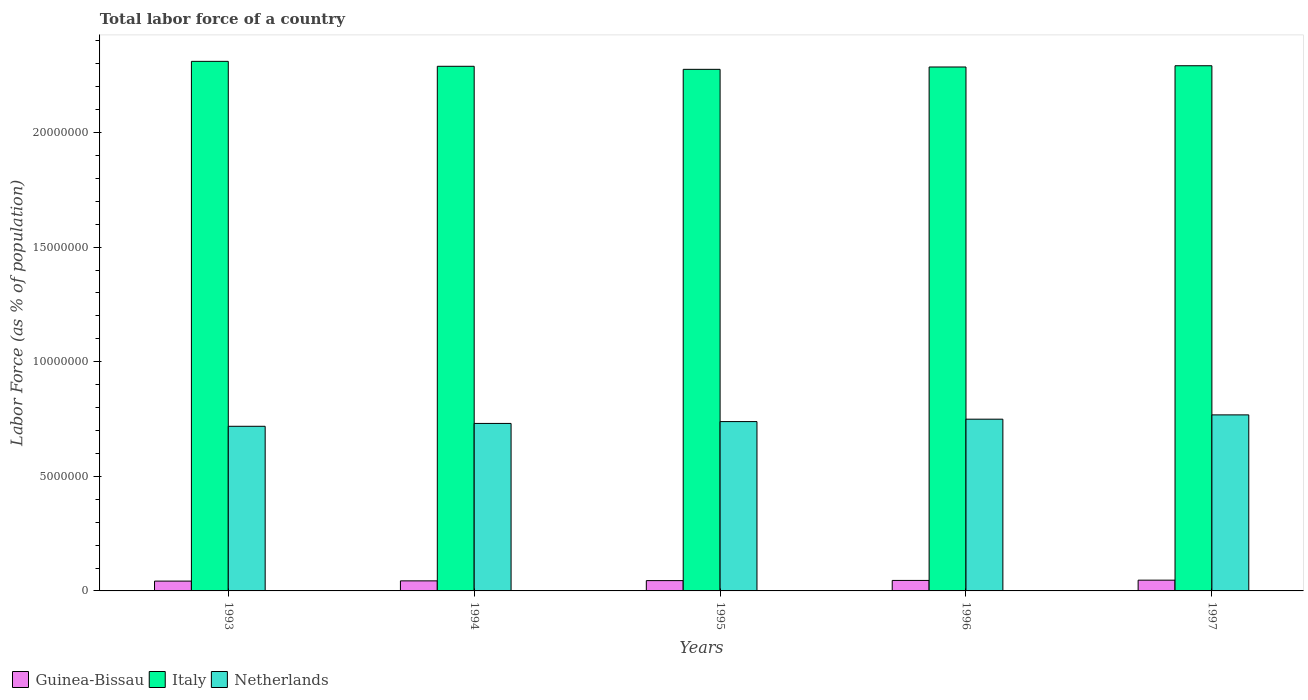How many groups of bars are there?
Provide a succinct answer. 5. Are the number of bars on each tick of the X-axis equal?
Ensure brevity in your answer.  Yes. How many bars are there on the 2nd tick from the right?
Provide a succinct answer. 3. What is the label of the 1st group of bars from the left?
Offer a very short reply. 1993. What is the percentage of labor force in Italy in 1996?
Your answer should be very brief. 2.29e+07. Across all years, what is the maximum percentage of labor force in Netherlands?
Make the answer very short. 7.68e+06. Across all years, what is the minimum percentage of labor force in Italy?
Your answer should be compact. 2.28e+07. What is the total percentage of labor force in Netherlands in the graph?
Your response must be concise. 3.71e+07. What is the difference between the percentage of labor force in Netherlands in 1995 and that in 1996?
Your answer should be very brief. -1.05e+05. What is the difference between the percentage of labor force in Netherlands in 1994 and the percentage of labor force in Guinea-Bissau in 1995?
Ensure brevity in your answer.  6.86e+06. What is the average percentage of labor force in Italy per year?
Your response must be concise. 2.29e+07. In the year 1997, what is the difference between the percentage of labor force in Guinea-Bissau and percentage of labor force in Netherlands?
Give a very brief answer. -7.21e+06. What is the ratio of the percentage of labor force in Italy in 1996 to that in 1997?
Your response must be concise. 1. Is the difference between the percentage of labor force in Guinea-Bissau in 1996 and 1997 greater than the difference between the percentage of labor force in Netherlands in 1996 and 1997?
Give a very brief answer. Yes. What is the difference between the highest and the second highest percentage of labor force in Guinea-Bissau?
Make the answer very short. 1.15e+04. What is the difference between the highest and the lowest percentage of labor force in Guinea-Bissau?
Your answer should be compact. 4.11e+04. Is the sum of the percentage of labor force in Italy in 1994 and 1995 greater than the maximum percentage of labor force in Netherlands across all years?
Your response must be concise. Yes. What does the 3rd bar from the right in 1993 represents?
Keep it short and to the point. Guinea-Bissau. Are all the bars in the graph horizontal?
Make the answer very short. No. How many years are there in the graph?
Provide a short and direct response. 5. Where does the legend appear in the graph?
Keep it short and to the point. Bottom left. How are the legend labels stacked?
Provide a short and direct response. Horizontal. What is the title of the graph?
Your answer should be compact. Total labor force of a country. What is the label or title of the Y-axis?
Make the answer very short. Labor Force (as % of population). What is the Labor Force (as % of population) in Guinea-Bissau in 1993?
Give a very brief answer. 4.28e+05. What is the Labor Force (as % of population) in Italy in 1993?
Give a very brief answer. 2.31e+07. What is the Labor Force (as % of population) of Netherlands in 1993?
Give a very brief answer. 7.18e+06. What is the Labor Force (as % of population) in Guinea-Bissau in 1994?
Keep it short and to the point. 4.39e+05. What is the Labor Force (as % of population) in Italy in 1994?
Provide a succinct answer. 2.29e+07. What is the Labor Force (as % of population) of Netherlands in 1994?
Your answer should be compact. 7.31e+06. What is the Labor Force (as % of population) of Guinea-Bissau in 1995?
Offer a very short reply. 4.50e+05. What is the Labor Force (as % of population) of Italy in 1995?
Provide a succinct answer. 2.28e+07. What is the Labor Force (as % of population) in Netherlands in 1995?
Give a very brief answer. 7.39e+06. What is the Labor Force (as % of population) of Guinea-Bissau in 1996?
Ensure brevity in your answer.  4.58e+05. What is the Labor Force (as % of population) in Italy in 1996?
Your answer should be very brief. 2.29e+07. What is the Labor Force (as % of population) of Netherlands in 1996?
Your answer should be compact. 7.49e+06. What is the Labor Force (as % of population) of Guinea-Bissau in 1997?
Offer a very short reply. 4.69e+05. What is the Labor Force (as % of population) of Italy in 1997?
Make the answer very short. 2.29e+07. What is the Labor Force (as % of population) of Netherlands in 1997?
Provide a succinct answer. 7.68e+06. Across all years, what is the maximum Labor Force (as % of population) of Guinea-Bissau?
Your response must be concise. 4.69e+05. Across all years, what is the maximum Labor Force (as % of population) in Italy?
Offer a terse response. 2.31e+07. Across all years, what is the maximum Labor Force (as % of population) in Netherlands?
Provide a succinct answer. 7.68e+06. Across all years, what is the minimum Labor Force (as % of population) of Guinea-Bissau?
Your answer should be very brief. 4.28e+05. Across all years, what is the minimum Labor Force (as % of population) in Italy?
Your response must be concise. 2.28e+07. Across all years, what is the minimum Labor Force (as % of population) of Netherlands?
Your answer should be very brief. 7.18e+06. What is the total Labor Force (as % of population) in Guinea-Bissau in the graph?
Give a very brief answer. 2.24e+06. What is the total Labor Force (as % of population) in Italy in the graph?
Make the answer very short. 1.15e+08. What is the total Labor Force (as % of population) in Netherlands in the graph?
Your answer should be very brief. 3.71e+07. What is the difference between the Labor Force (as % of population) of Guinea-Bissau in 1993 and that in 1994?
Your answer should be very brief. -1.04e+04. What is the difference between the Labor Force (as % of population) in Italy in 1993 and that in 1994?
Your answer should be compact. 2.16e+05. What is the difference between the Labor Force (as % of population) of Netherlands in 1993 and that in 1994?
Give a very brief answer. -1.25e+05. What is the difference between the Labor Force (as % of population) of Guinea-Bissau in 1993 and that in 1995?
Provide a short and direct response. -2.13e+04. What is the difference between the Labor Force (as % of population) of Italy in 1993 and that in 1995?
Offer a terse response. 3.48e+05. What is the difference between the Labor Force (as % of population) in Netherlands in 1993 and that in 1995?
Make the answer very short. -2.05e+05. What is the difference between the Labor Force (as % of population) in Guinea-Bissau in 1993 and that in 1996?
Your response must be concise. -2.95e+04. What is the difference between the Labor Force (as % of population) of Italy in 1993 and that in 1996?
Provide a short and direct response. 2.46e+05. What is the difference between the Labor Force (as % of population) in Netherlands in 1993 and that in 1996?
Provide a short and direct response. -3.10e+05. What is the difference between the Labor Force (as % of population) in Guinea-Bissau in 1993 and that in 1997?
Offer a very short reply. -4.11e+04. What is the difference between the Labor Force (as % of population) of Italy in 1993 and that in 1997?
Offer a very short reply. 1.92e+05. What is the difference between the Labor Force (as % of population) in Netherlands in 1993 and that in 1997?
Offer a very short reply. -4.97e+05. What is the difference between the Labor Force (as % of population) in Guinea-Bissau in 1994 and that in 1995?
Your answer should be very brief. -1.09e+04. What is the difference between the Labor Force (as % of population) in Italy in 1994 and that in 1995?
Keep it short and to the point. 1.32e+05. What is the difference between the Labor Force (as % of population) of Netherlands in 1994 and that in 1995?
Provide a succinct answer. -8.04e+04. What is the difference between the Labor Force (as % of population) of Guinea-Bissau in 1994 and that in 1996?
Keep it short and to the point. -1.91e+04. What is the difference between the Labor Force (as % of population) in Italy in 1994 and that in 1996?
Your answer should be very brief. 3.06e+04. What is the difference between the Labor Force (as % of population) of Netherlands in 1994 and that in 1996?
Your answer should be compact. -1.85e+05. What is the difference between the Labor Force (as % of population) in Guinea-Bissau in 1994 and that in 1997?
Provide a short and direct response. -3.06e+04. What is the difference between the Labor Force (as % of population) in Italy in 1994 and that in 1997?
Make the answer very short. -2.41e+04. What is the difference between the Labor Force (as % of population) in Netherlands in 1994 and that in 1997?
Give a very brief answer. -3.72e+05. What is the difference between the Labor Force (as % of population) in Guinea-Bissau in 1995 and that in 1996?
Ensure brevity in your answer.  -8254. What is the difference between the Labor Force (as % of population) in Italy in 1995 and that in 1996?
Provide a succinct answer. -1.02e+05. What is the difference between the Labor Force (as % of population) of Netherlands in 1995 and that in 1996?
Ensure brevity in your answer.  -1.05e+05. What is the difference between the Labor Force (as % of population) of Guinea-Bissau in 1995 and that in 1997?
Your response must be concise. -1.98e+04. What is the difference between the Labor Force (as % of population) in Italy in 1995 and that in 1997?
Keep it short and to the point. -1.57e+05. What is the difference between the Labor Force (as % of population) in Netherlands in 1995 and that in 1997?
Your answer should be compact. -2.92e+05. What is the difference between the Labor Force (as % of population) in Guinea-Bissau in 1996 and that in 1997?
Your answer should be compact. -1.15e+04. What is the difference between the Labor Force (as % of population) of Italy in 1996 and that in 1997?
Offer a very short reply. -5.46e+04. What is the difference between the Labor Force (as % of population) in Netherlands in 1996 and that in 1997?
Your answer should be very brief. -1.87e+05. What is the difference between the Labor Force (as % of population) in Guinea-Bissau in 1993 and the Labor Force (as % of population) in Italy in 1994?
Give a very brief answer. -2.25e+07. What is the difference between the Labor Force (as % of population) in Guinea-Bissau in 1993 and the Labor Force (as % of population) in Netherlands in 1994?
Make the answer very short. -6.88e+06. What is the difference between the Labor Force (as % of population) of Italy in 1993 and the Labor Force (as % of population) of Netherlands in 1994?
Provide a succinct answer. 1.58e+07. What is the difference between the Labor Force (as % of population) in Guinea-Bissau in 1993 and the Labor Force (as % of population) in Italy in 1995?
Ensure brevity in your answer.  -2.23e+07. What is the difference between the Labor Force (as % of population) in Guinea-Bissau in 1993 and the Labor Force (as % of population) in Netherlands in 1995?
Offer a very short reply. -6.96e+06. What is the difference between the Labor Force (as % of population) of Italy in 1993 and the Labor Force (as % of population) of Netherlands in 1995?
Keep it short and to the point. 1.57e+07. What is the difference between the Labor Force (as % of population) in Guinea-Bissau in 1993 and the Labor Force (as % of population) in Italy in 1996?
Your answer should be compact. -2.24e+07. What is the difference between the Labor Force (as % of population) in Guinea-Bissau in 1993 and the Labor Force (as % of population) in Netherlands in 1996?
Offer a terse response. -7.06e+06. What is the difference between the Labor Force (as % of population) of Italy in 1993 and the Labor Force (as % of population) of Netherlands in 1996?
Make the answer very short. 1.56e+07. What is the difference between the Labor Force (as % of population) of Guinea-Bissau in 1993 and the Labor Force (as % of population) of Italy in 1997?
Provide a short and direct response. -2.25e+07. What is the difference between the Labor Force (as % of population) of Guinea-Bissau in 1993 and the Labor Force (as % of population) of Netherlands in 1997?
Offer a terse response. -7.25e+06. What is the difference between the Labor Force (as % of population) in Italy in 1993 and the Labor Force (as % of population) in Netherlands in 1997?
Your answer should be compact. 1.54e+07. What is the difference between the Labor Force (as % of population) in Guinea-Bissau in 1994 and the Labor Force (as % of population) in Italy in 1995?
Provide a succinct answer. -2.23e+07. What is the difference between the Labor Force (as % of population) of Guinea-Bissau in 1994 and the Labor Force (as % of population) of Netherlands in 1995?
Your answer should be very brief. -6.95e+06. What is the difference between the Labor Force (as % of population) of Italy in 1994 and the Labor Force (as % of population) of Netherlands in 1995?
Make the answer very short. 1.55e+07. What is the difference between the Labor Force (as % of population) of Guinea-Bissau in 1994 and the Labor Force (as % of population) of Italy in 1996?
Your response must be concise. -2.24e+07. What is the difference between the Labor Force (as % of population) in Guinea-Bissau in 1994 and the Labor Force (as % of population) in Netherlands in 1996?
Your response must be concise. -7.05e+06. What is the difference between the Labor Force (as % of population) in Italy in 1994 and the Labor Force (as % of population) in Netherlands in 1996?
Offer a very short reply. 1.54e+07. What is the difference between the Labor Force (as % of population) in Guinea-Bissau in 1994 and the Labor Force (as % of population) in Italy in 1997?
Offer a terse response. -2.25e+07. What is the difference between the Labor Force (as % of population) of Guinea-Bissau in 1994 and the Labor Force (as % of population) of Netherlands in 1997?
Offer a terse response. -7.24e+06. What is the difference between the Labor Force (as % of population) in Italy in 1994 and the Labor Force (as % of population) in Netherlands in 1997?
Give a very brief answer. 1.52e+07. What is the difference between the Labor Force (as % of population) of Guinea-Bissau in 1995 and the Labor Force (as % of population) of Italy in 1996?
Give a very brief answer. -2.24e+07. What is the difference between the Labor Force (as % of population) of Guinea-Bissau in 1995 and the Labor Force (as % of population) of Netherlands in 1996?
Provide a succinct answer. -7.04e+06. What is the difference between the Labor Force (as % of population) in Italy in 1995 and the Labor Force (as % of population) in Netherlands in 1996?
Your answer should be very brief. 1.53e+07. What is the difference between the Labor Force (as % of population) of Guinea-Bissau in 1995 and the Labor Force (as % of population) of Italy in 1997?
Offer a terse response. -2.25e+07. What is the difference between the Labor Force (as % of population) in Guinea-Bissau in 1995 and the Labor Force (as % of population) in Netherlands in 1997?
Provide a short and direct response. -7.23e+06. What is the difference between the Labor Force (as % of population) in Italy in 1995 and the Labor Force (as % of population) in Netherlands in 1997?
Your answer should be very brief. 1.51e+07. What is the difference between the Labor Force (as % of population) of Guinea-Bissau in 1996 and the Labor Force (as % of population) of Italy in 1997?
Offer a very short reply. -2.25e+07. What is the difference between the Labor Force (as % of population) in Guinea-Bissau in 1996 and the Labor Force (as % of population) in Netherlands in 1997?
Keep it short and to the point. -7.22e+06. What is the difference between the Labor Force (as % of population) in Italy in 1996 and the Labor Force (as % of population) in Netherlands in 1997?
Keep it short and to the point. 1.52e+07. What is the average Labor Force (as % of population) of Guinea-Bissau per year?
Provide a short and direct response. 4.49e+05. What is the average Labor Force (as % of population) of Italy per year?
Provide a short and direct response. 2.29e+07. What is the average Labor Force (as % of population) in Netherlands per year?
Ensure brevity in your answer.  7.41e+06. In the year 1993, what is the difference between the Labor Force (as % of population) of Guinea-Bissau and Labor Force (as % of population) of Italy?
Offer a very short reply. -2.27e+07. In the year 1993, what is the difference between the Labor Force (as % of population) of Guinea-Bissau and Labor Force (as % of population) of Netherlands?
Keep it short and to the point. -6.75e+06. In the year 1993, what is the difference between the Labor Force (as % of population) of Italy and Labor Force (as % of population) of Netherlands?
Keep it short and to the point. 1.59e+07. In the year 1994, what is the difference between the Labor Force (as % of population) of Guinea-Bissau and Labor Force (as % of population) of Italy?
Provide a succinct answer. -2.24e+07. In the year 1994, what is the difference between the Labor Force (as % of population) in Guinea-Bissau and Labor Force (as % of population) in Netherlands?
Give a very brief answer. -6.87e+06. In the year 1994, what is the difference between the Labor Force (as % of population) of Italy and Labor Force (as % of population) of Netherlands?
Your response must be concise. 1.56e+07. In the year 1995, what is the difference between the Labor Force (as % of population) in Guinea-Bissau and Labor Force (as % of population) in Italy?
Give a very brief answer. -2.23e+07. In the year 1995, what is the difference between the Labor Force (as % of population) of Guinea-Bissau and Labor Force (as % of population) of Netherlands?
Make the answer very short. -6.94e+06. In the year 1995, what is the difference between the Labor Force (as % of population) of Italy and Labor Force (as % of population) of Netherlands?
Give a very brief answer. 1.54e+07. In the year 1996, what is the difference between the Labor Force (as % of population) of Guinea-Bissau and Labor Force (as % of population) of Italy?
Ensure brevity in your answer.  -2.24e+07. In the year 1996, what is the difference between the Labor Force (as % of population) in Guinea-Bissau and Labor Force (as % of population) in Netherlands?
Keep it short and to the point. -7.03e+06. In the year 1996, what is the difference between the Labor Force (as % of population) in Italy and Labor Force (as % of population) in Netherlands?
Keep it short and to the point. 1.54e+07. In the year 1997, what is the difference between the Labor Force (as % of population) in Guinea-Bissau and Labor Force (as % of population) in Italy?
Provide a succinct answer. -2.24e+07. In the year 1997, what is the difference between the Labor Force (as % of population) in Guinea-Bissau and Labor Force (as % of population) in Netherlands?
Ensure brevity in your answer.  -7.21e+06. In the year 1997, what is the difference between the Labor Force (as % of population) of Italy and Labor Force (as % of population) of Netherlands?
Offer a terse response. 1.52e+07. What is the ratio of the Labor Force (as % of population) in Guinea-Bissau in 1993 to that in 1994?
Keep it short and to the point. 0.98. What is the ratio of the Labor Force (as % of population) in Italy in 1993 to that in 1994?
Give a very brief answer. 1.01. What is the ratio of the Labor Force (as % of population) in Netherlands in 1993 to that in 1994?
Give a very brief answer. 0.98. What is the ratio of the Labor Force (as % of population) in Guinea-Bissau in 1993 to that in 1995?
Your answer should be very brief. 0.95. What is the ratio of the Labor Force (as % of population) of Italy in 1993 to that in 1995?
Offer a very short reply. 1.02. What is the ratio of the Labor Force (as % of population) in Netherlands in 1993 to that in 1995?
Keep it short and to the point. 0.97. What is the ratio of the Labor Force (as % of population) of Guinea-Bissau in 1993 to that in 1996?
Offer a terse response. 0.94. What is the ratio of the Labor Force (as % of population) of Italy in 1993 to that in 1996?
Your response must be concise. 1.01. What is the ratio of the Labor Force (as % of population) in Netherlands in 1993 to that in 1996?
Make the answer very short. 0.96. What is the ratio of the Labor Force (as % of population) of Guinea-Bissau in 1993 to that in 1997?
Your answer should be very brief. 0.91. What is the ratio of the Labor Force (as % of population) of Italy in 1993 to that in 1997?
Your answer should be very brief. 1.01. What is the ratio of the Labor Force (as % of population) of Netherlands in 1993 to that in 1997?
Give a very brief answer. 0.94. What is the ratio of the Labor Force (as % of population) in Guinea-Bissau in 1994 to that in 1995?
Offer a very short reply. 0.98. What is the ratio of the Labor Force (as % of population) in Italy in 1994 to that in 1995?
Offer a very short reply. 1.01. What is the ratio of the Labor Force (as % of population) in Netherlands in 1994 to that in 1995?
Ensure brevity in your answer.  0.99. What is the ratio of the Labor Force (as % of population) in Guinea-Bissau in 1994 to that in 1996?
Provide a short and direct response. 0.96. What is the ratio of the Labor Force (as % of population) in Italy in 1994 to that in 1996?
Keep it short and to the point. 1. What is the ratio of the Labor Force (as % of population) in Netherlands in 1994 to that in 1996?
Give a very brief answer. 0.98. What is the ratio of the Labor Force (as % of population) of Guinea-Bissau in 1994 to that in 1997?
Give a very brief answer. 0.93. What is the ratio of the Labor Force (as % of population) of Italy in 1994 to that in 1997?
Keep it short and to the point. 1. What is the ratio of the Labor Force (as % of population) of Netherlands in 1994 to that in 1997?
Offer a very short reply. 0.95. What is the ratio of the Labor Force (as % of population) in Netherlands in 1995 to that in 1996?
Your response must be concise. 0.99. What is the ratio of the Labor Force (as % of population) of Guinea-Bissau in 1995 to that in 1997?
Keep it short and to the point. 0.96. What is the ratio of the Labor Force (as % of population) in Guinea-Bissau in 1996 to that in 1997?
Your answer should be very brief. 0.98. What is the ratio of the Labor Force (as % of population) in Italy in 1996 to that in 1997?
Keep it short and to the point. 1. What is the ratio of the Labor Force (as % of population) in Netherlands in 1996 to that in 1997?
Keep it short and to the point. 0.98. What is the difference between the highest and the second highest Labor Force (as % of population) of Guinea-Bissau?
Offer a terse response. 1.15e+04. What is the difference between the highest and the second highest Labor Force (as % of population) in Italy?
Your answer should be compact. 1.92e+05. What is the difference between the highest and the second highest Labor Force (as % of population) of Netherlands?
Keep it short and to the point. 1.87e+05. What is the difference between the highest and the lowest Labor Force (as % of population) in Guinea-Bissau?
Give a very brief answer. 4.11e+04. What is the difference between the highest and the lowest Labor Force (as % of population) of Italy?
Ensure brevity in your answer.  3.48e+05. What is the difference between the highest and the lowest Labor Force (as % of population) of Netherlands?
Your response must be concise. 4.97e+05. 